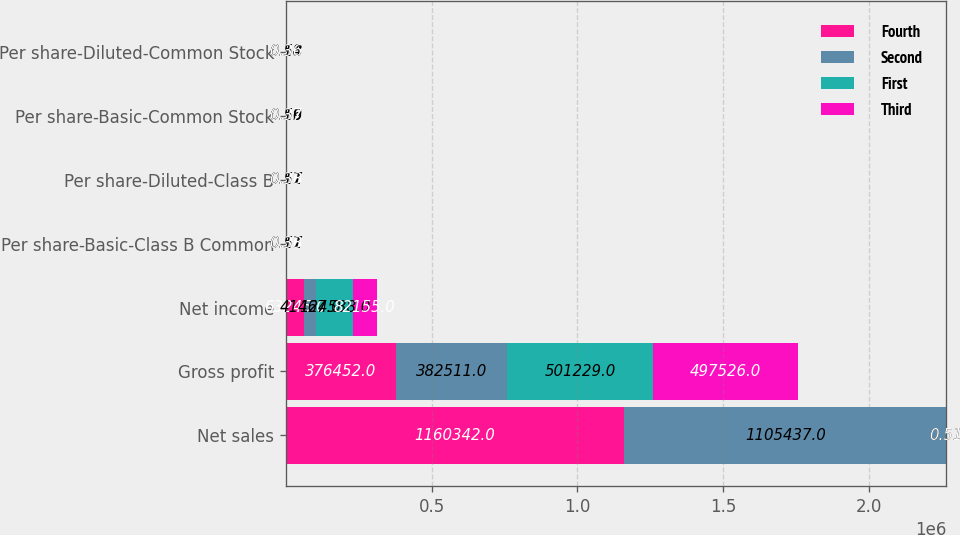Convert chart to OTSL. <chart><loc_0><loc_0><loc_500><loc_500><stacked_bar_chart><ecel><fcel>Net sales<fcel>Gross profit<fcel>Net income<fcel>Per share-Basic-Class B Common<fcel>Per share-Diluted-Class B<fcel>Per share-Basic-Common Stock<fcel>Per share-Diluted-Common Stock<nl><fcel>Fourth<fcel>1.16034e+06<fcel>376452<fcel>63245<fcel>0.26<fcel>0.26<fcel>0.29<fcel>0.28<nl><fcel>Second<fcel>1.10544e+06<fcel>382511<fcel>41467<fcel>0.17<fcel>0.17<fcel>0.19<fcel>0.18<nl><fcel>First<fcel>0.51<fcel>501229<fcel>124538<fcel>0.51<fcel>0.51<fcel>0.56<fcel>0.54<nl><fcel>Third<fcel>0.51<fcel>497526<fcel>82155<fcel>0.33<fcel>0.33<fcel>0.37<fcel>0.36<nl></chart> 